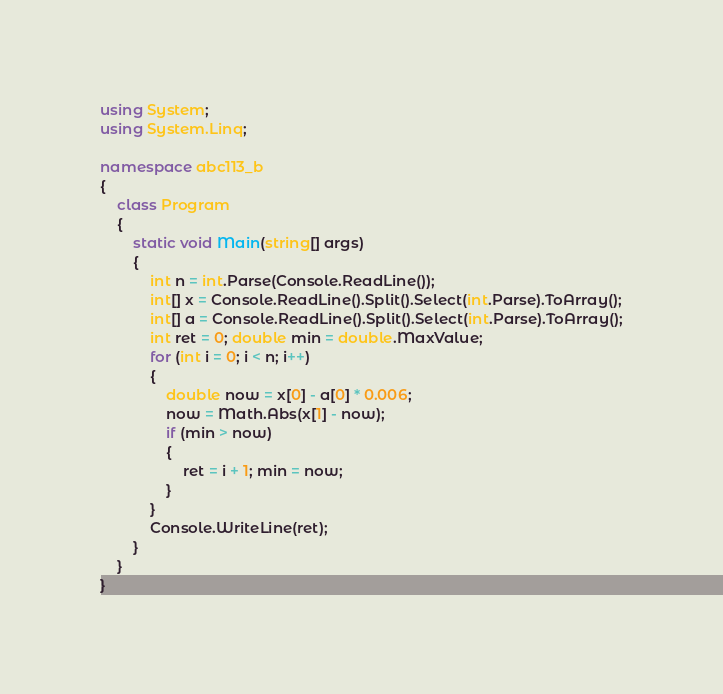Convert code to text. <code><loc_0><loc_0><loc_500><loc_500><_C#_>using System;
using System.Linq;

namespace abc113_b
{
	class Program
	{
		static void Main(string[] args)
		{
			int n = int.Parse(Console.ReadLine());
			int[] x = Console.ReadLine().Split().Select(int.Parse).ToArray();
			int[] a = Console.ReadLine().Split().Select(int.Parse).ToArray();
			int ret = 0; double min = double.MaxValue;
			for (int i = 0; i < n; i++)
			{
				double now = x[0] - a[0] * 0.006;
				now = Math.Abs(x[1] - now);
				if (min > now)
				{
					ret = i + 1; min = now;
				}
			}
			Console.WriteLine(ret);
		}
	}
}</code> 